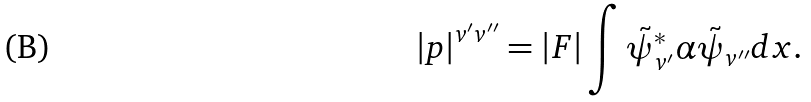Convert formula to latex. <formula><loc_0><loc_0><loc_500><loc_500>\left | { p } \right | ^ { v ^ { \prime } v ^ { \prime \prime } } = | { F } | \int \tilde { \psi } _ { v ^ { \prime } } ^ { \ast } \alpha \tilde { \psi } _ { v ^ { \prime \prime } } d x .</formula> 